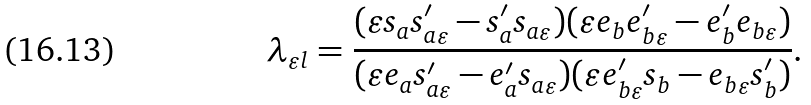<formula> <loc_0><loc_0><loc_500><loc_500>\lambda _ { \varepsilon l } = \frac { ( \varepsilon s _ { a } s _ { a \varepsilon } ^ { \prime } - s _ { a } ^ { \prime } s _ { a \varepsilon } ) ( \varepsilon e _ { b } e _ { b \varepsilon } ^ { \prime } - e _ { b } ^ { \prime } e _ { b \varepsilon } ) } { ( \varepsilon e _ { a } s _ { a \varepsilon } ^ { \prime } - e _ { a } ^ { \prime } s _ { a \varepsilon } ) ( \varepsilon e _ { b \varepsilon } ^ { \prime } s _ { b } - e _ { b \varepsilon } s _ { b } ^ { \prime } ) } .</formula> 